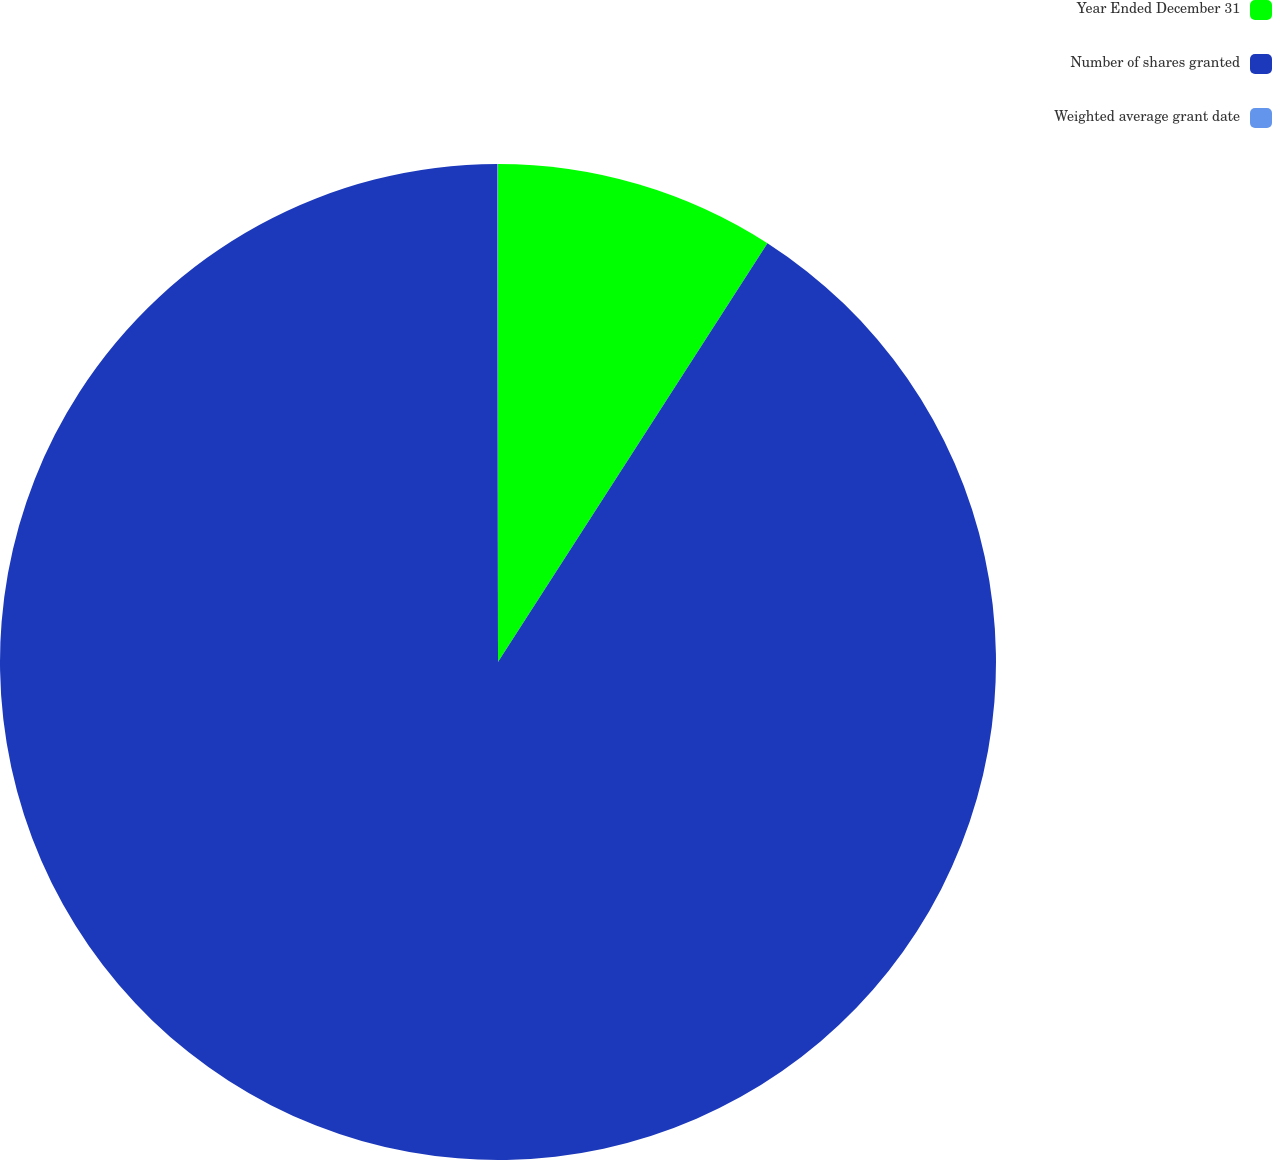Convert chart. <chart><loc_0><loc_0><loc_500><loc_500><pie_chart><fcel>Year Ended December 31<fcel>Number of shares granted<fcel>Weighted average grant date<nl><fcel>9.1%<fcel>90.88%<fcel>0.02%<nl></chart> 